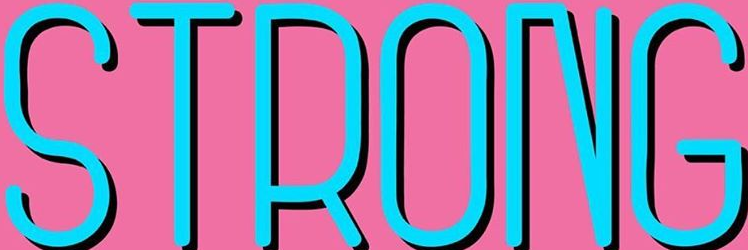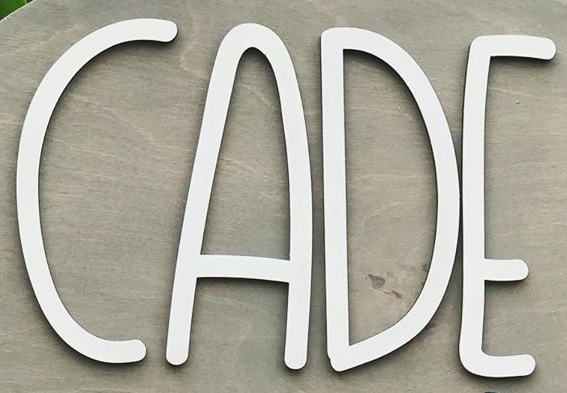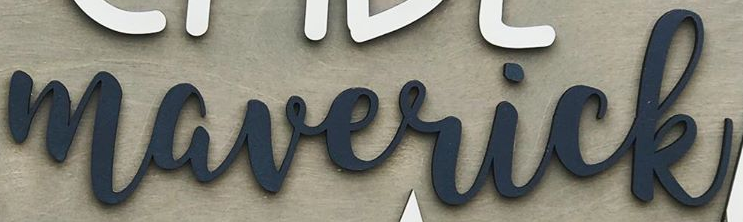Read the text content from these images in order, separated by a semicolon. STRONG; ACDE; maverick 